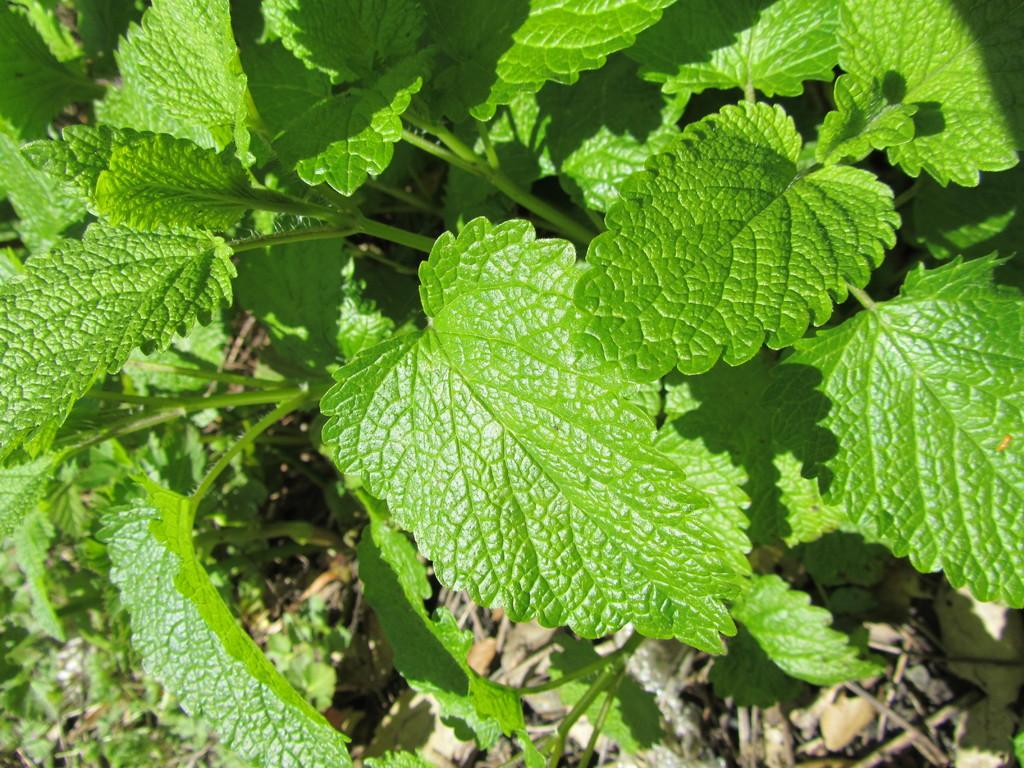What type of plant material is present in the image? There are mint leaves in the image. How many mice can be seen climbing the mint leaves in the image? There are no mice present in the image; it only features mint leaves. What stage of development is the mint plant in the image? The provided facts do not give information about the development stage of the mint leaves. 